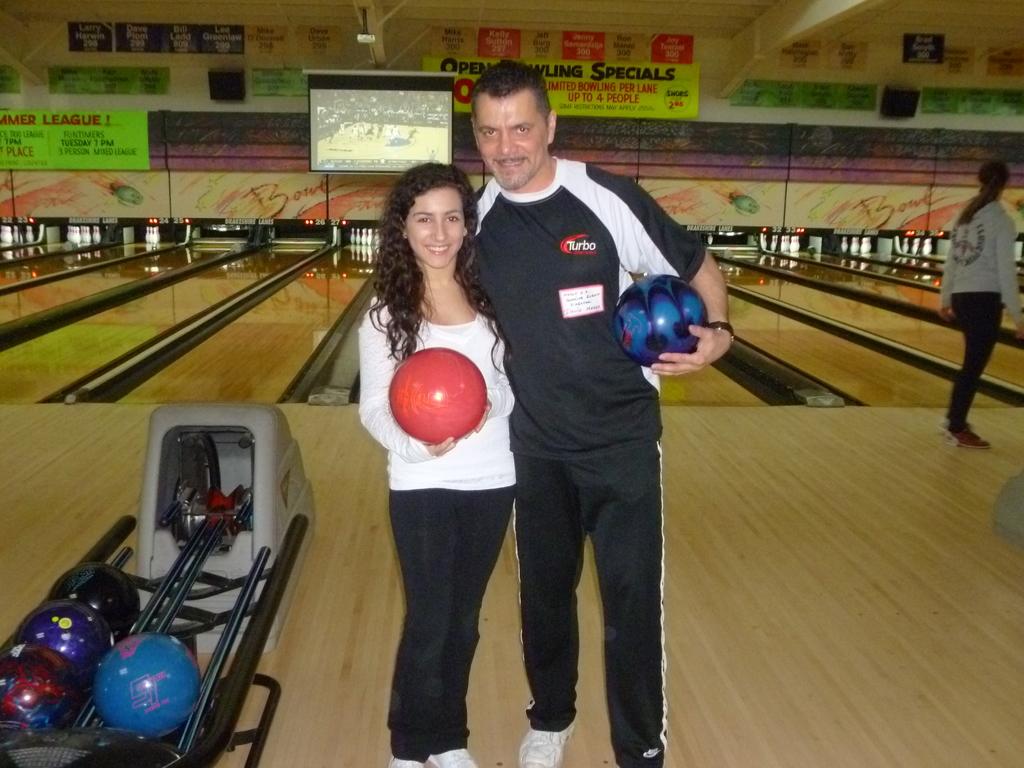What word is on the man's shirt?
Provide a short and direct response. Turbo. 